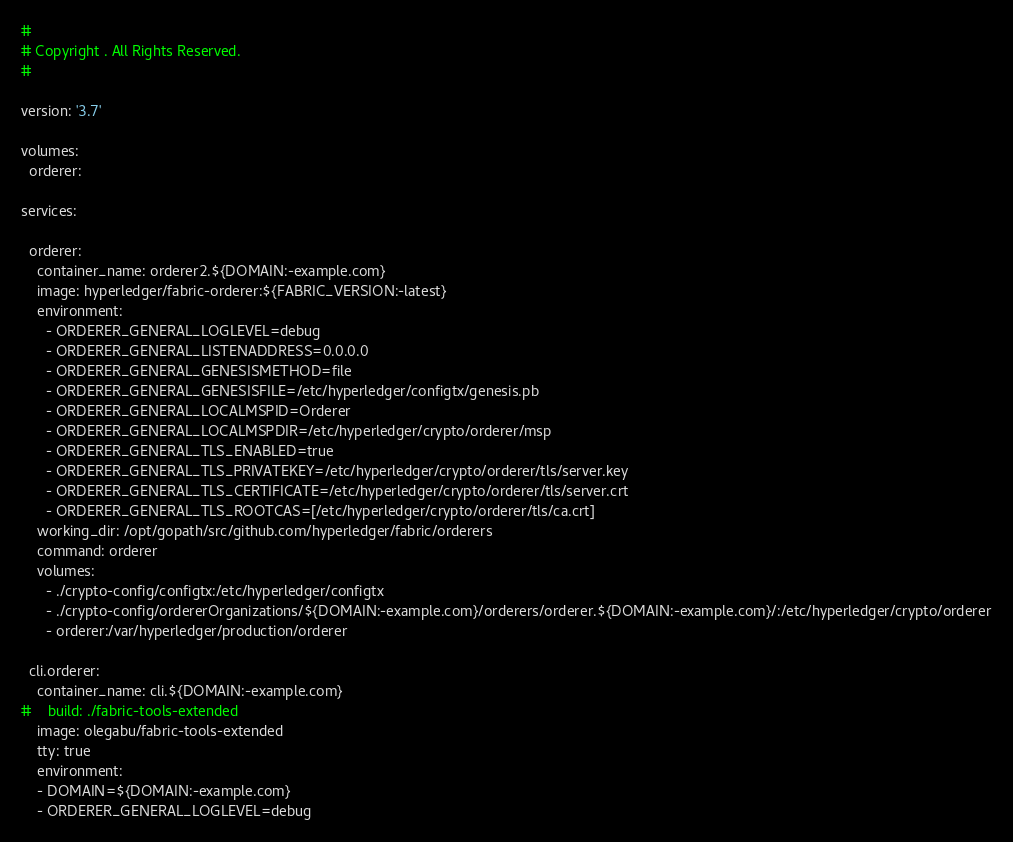Convert code to text. <code><loc_0><loc_0><loc_500><loc_500><_YAML_># 
# Copyright . All Rights Reserved.
# 

version: '3.7'

volumes:
  orderer:

services:

  orderer:
    container_name: orderer2.${DOMAIN:-example.com}
    image: hyperledger/fabric-orderer:${FABRIC_VERSION:-latest}
    environment:
      - ORDERER_GENERAL_LOGLEVEL=debug
      - ORDERER_GENERAL_LISTENADDRESS=0.0.0.0
      - ORDERER_GENERAL_GENESISMETHOD=file
      - ORDERER_GENERAL_GENESISFILE=/etc/hyperledger/configtx/genesis.pb
      - ORDERER_GENERAL_LOCALMSPID=Orderer
      - ORDERER_GENERAL_LOCALMSPDIR=/etc/hyperledger/crypto/orderer/msp
      - ORDERER_GENERAL_TLS_ENABLED=true
      - ORDERER_GENERAL_TLS_PRIVATEKEY=/etc/hyperledger/crypto/orderer/tls/server.key
      - ORDERER_GENERAL_TLS_CERTIFICATE=/etc/hyperledger/crypto/orderer/tls/server.crt
      - ORDERER_GENERAL_TLS_ROOTCAS=[/etc/hyperledger/crypto/orderer/tls/ca.crt]
    working_dir: /opt/gopath/src/github.com/hyperledger/fabric/orderers
    command: orderer
    volumes:
      - ./crypto-config/configtx:/etc/hyperledger/configtx
      - ./crypto-config/ordererOrganizations/${DOMAIN:-example.com}/orderers/orderer.${DOMAIN:-example.com}/:/etc/hyperledger/crypto/orderer
      - orderer:/var/hyperledger/production/orderer

  cli.orderer:
    container_name: cli.${DOMAIN:-example.com}
#    build: ./fabric-tools-extended
    image: olegabu/fabric-tools-extended
    tty: true
    environment:
    - DOMAIN=${DOMAIN:-example.com}
    - ORDERER_GENERAL_LOGLEVEL=debug</code> 